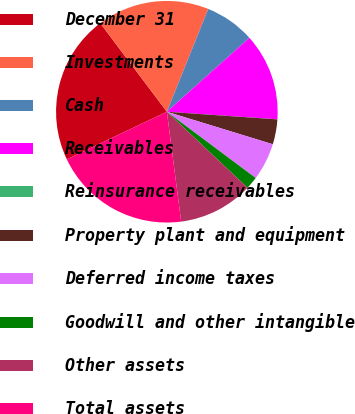Convert chart. <chart><loc_0><loc_0><loc_500><loc_500><pie_chart><fcel>December 31<fcel>Investments<fcel>Cash<fcel>Receivables<fcel>Reinsurance receivables<fcel>Property plant and equipment<fcel>Deferred income taxes<fcel>Goodwill and other intangible<fcel>Other assets<fcel>Total assets<nl><fcel>21.81%<fcel>16.36%<fcel>7.28%<fcel>12.72%<fcel>0.01%<fcel>3.64%<fcel>5.46%<fcel>1.83%<fcel>10.91%<fcel>19.99%<nl></chart> 